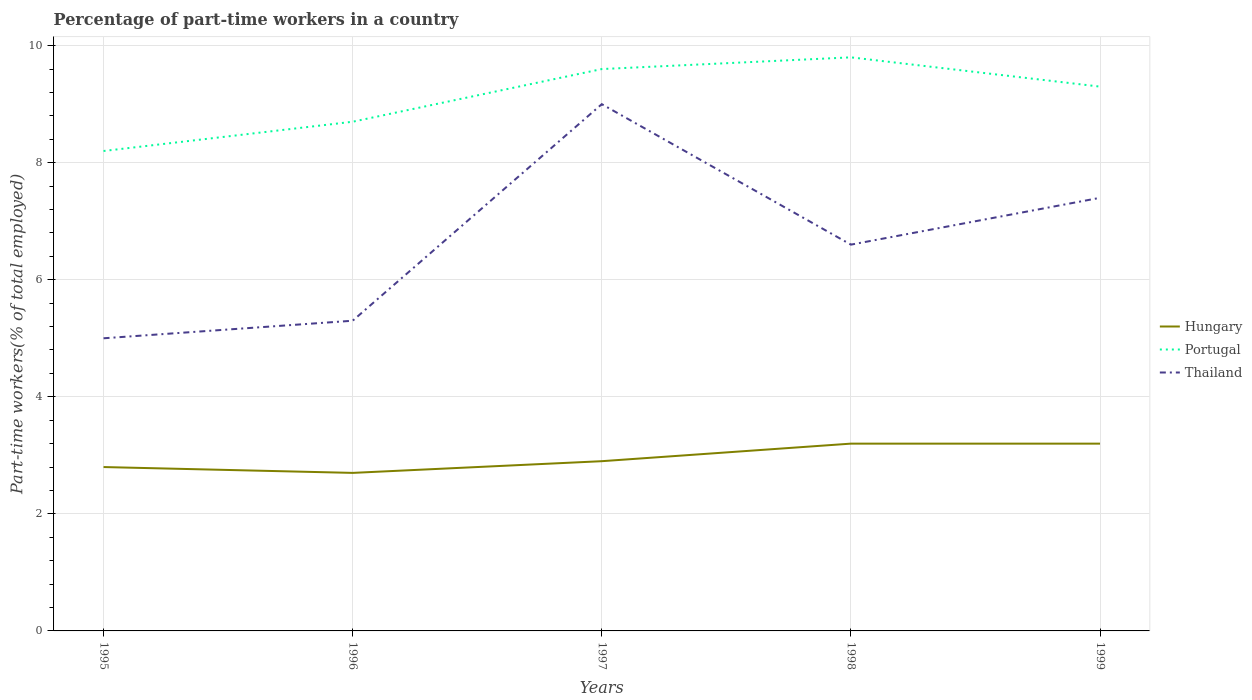How many different coloured lines are there?
Offer a very short reply. 3. Across all years, what is the maximum percentage of part-time workers in Hungary?
Keep it short and to the point. 2.7. What is the total percentage of part-time workers in Portugal in the graph?
Offer a terse response. -0.2. Is the percentage of part-time workers in Hungary strictly greater than the percentage of part-time workers in Thailand over the years?
Provide a succinct answer. Yes. How many lines are there?
Give a very brief answer. 3. How many years are there in the graph?
Your answer should be very brief. 5. Does the graph contain any zero values?
Provide a succinct answer. No. Does the graph contain grids?
Your response must be concise. Yes. How many legend labels are there?
Make the answer very short. 3. What is the title of the graph?
Ensure brevity in your answer.  Percentage of part-time workers in a country. Does "South Sudan" appear as one of the legend labels in the graph?
Your response must be concise. No. What is the label or title of the X-axis?
Provide a short and direct response. Years. What is the label or title of the Y-axis?
Your answer should be very brief. Part-time workers(% of total employed). What is the Part-time workers(% of total employed) in Hungary in 1995?
Your answer should be very brief. 2.8. What is the Part-time workers(% of total employed) of Portugal in 1995?
Offer a very short reply. 8.2. What is the Part-time workers(% of total employed) in Hungary in 1996?
Your answer should be compact. 2.7. What is the Part-time workers(% of total employed) of Portugal in 1996?
Offer a terse response. 8.7. What is the Part-time workers(% of total employed) in Thailand in 1996?
Your answer should be very brief. 5.3. What is the Part-time workers(% of total employed) in Hungary in 1997?
Offer a very short reply. 2.9. What is the Part-time workers(% of total employed) of Portugal in 1997?
Your answer should be compact. 9.6. What is the Part-time workers(% of total employed) of Hungary in 1998?
Your answer should be very brief. 3.2. What is the Part-time workers(% of total employed) in Portugal in 1998?
Your answer should be compact. 9.8. What is the Part-time workers(% of total employed) of Thailand in 1998?
Provide a succinct answer. 6.6. What is the Part-time workers(% of total employed) of Hungary in 1999?
Provide a short and direct response. 3.2. What is the Part-time workers(% of total employed) of Portugal in 1999?
Your answer should be compact. 9.3. What is the Part-time workers(% of total employed) in Thailand in 1999?
Keep it short and to the point. 7.4. Across all years, what is the maximum Part-time workers(% of total employed) of Hungary?
Offer a very short reply. 3.2. Across all years, what is the maximum Part-time workers(% of total employed) in Portugal?
Keep it short and to the point. 9.8. Across all years, what is the maximum Part-time workers(% of total employed) in Thailand?
Your response must be concise. 9. Across all years, what is the minimum Part-time workers(% of total employed) of Hungary?
Offer a very short reply. 2.7. Across all years, what is the minimum Part-time workers(% of total employed) in Portugal?
Provide a succinct answer. 8.2. What is the total Part-time workers(% of total employed) in Portugal in the graph?
Your answer should be compact. 45.6. What is the total Part-time workers(% of total employed) of Thailand in the graph?
Ensure brevity in your answer.  33.3. What is the difference between the Part-time workers(% of total employed) in Portugal in 1995 and that in 1997?
Offer a terse response. -1.4. What is the difference between the Part-time workers(% of total employed) in Hungary in 1995 and that in 1998?
Offer a very short reply. -0.4. What is the difference between the Part-time workers(% of total employed) in Thailand in 1995 and that in 1998?
Provide a short and direct response. -1.6. What is the difference between the Part-time workers(% of total employed) of Hungary in 1995 and that in 1999?
Your answer should be very brief. -0.4. What is the difference between the Part-time workers(% of total employed) in Portugal in 1995 and that in 1999?
Give a very brief answer. -1.1. What is the difference between the Part-time workers(% of total employed) of Hungary in 1996 and that in 1997?
Offer a very short reply. -0.2. What is the difference between the Part-time workers(% of total employed) of Portugal in 1996 and that in 1997?
Give a very brief answer. -0.9. What is the difference between the Part-time workers(% of total employed) of Thailand in 1996 and that in 1997?
Ensure brevity in your answer.  -3.7. What is the difference between the Part-time workers(% of total employed) of Hungary in 1996 and that in 1998?
Ensure brevity in your answer.  -0.5. What is the difference between the Part-time workers(% of total employed) of Portugal in 1996 and that in 1998?
Your answer should be very brief. -1.1. What is the difference between the Part-time workers(% of total employed) of Thailand in 1996 and that in 1998?
Keep it short and to the point. -1.3. What is the difference between the Part-time workers(% of total employed) of Hungary in 1996 and that in 1999?
Provide a short and direct response. -0.5. What is the difference between the Part-time workers(% of total employed) of Portugal in 1996 and that in 1999?
Your answer should be compact. -0.6. What is the difference between the Part-time workers(% of total employed) of Hungary in 1997 and that in 1998?
Your answer should be compact. -0.3. What is the difference between the Part-time workers(% of total employed) in Hungary in 1997 and that in 1999?
Provide a succinct answer. -0.3. What is the difference between the Part-time workers(% of total employed) in Portugal in 1997 and that in 1999?
Your answer should be compact. 0.3. What is the difference between the Part-time workers(% of total employed) in Portugal in 1998 and that in 1999?
Make the answer very short. 0.5. What is the difference between the Part-time workers(% of total employed) in Hungary in 1995 and the Part-time workers(% of total employed) in Portugal in 1996?
Offer a terse response. -5.9. What is the difference between the Part-time workers(% of total employed) of Hungary in 1995 and the Part-time workers(% of total employed) of Thailand in 1996?
Make the answer very short. -2.5. What is the difference between the Part-time workers(% of total employed) in Hungary in 1995 and the Part-time workers(% of total employed) in Portugal in 1997?
Give a very brief answer. -6.8. What is the difference between the Part-time workers(% of total employed) of Hungary in 1995 and the Part-time workers(% of total employed) of Thailand in 1997?
Your response must be concise. -6.2. What is the difference between the Part-time workers(% of total employed) of Hungary in 1995 and the Part-time workers(% of total employed) of Portugal in 1998?
Provide a succinct answer. -7. What is the difference between the Part-time workers(% of total employed) of Hungary in 1995 and the Part-time workers(% of total employed) of Thailand in 1998?
Make the answer very short. -3.8. What is the difference between the Part-time workers(% of total employed) of Portugal in 1995 and the Part-time workers(% of total employed) of Thailand in 1998?
Provide a short and direct response. 1.6. What is the difference between the Part-time workers(% of total employed) of Hungary in 1995 and the Part-time workers(% of total employed) of Portugal in 1999?
Your response must be concise. -6.5. What is the difference between the Part-time workers(% of total employed) in Portugal in 1995 and the Part-time workers(% of total employed) in Thailand in 1999?
Offer a very short reply. 0.8. What is the difference between the Part-time workers(% of total employed) in Hungary in 1996 and the Part-time workers(% of total employed) in Thailand in 1997?
Make the answer very short. -6.3. What is the difference between the Part-time workers(% of total employed) of Portugal in 1996 and the Part-time workers(% of total employed) of Thailand in 1997?
Your response must be concise. -0.3. What is the difference between the Part-time workers(% of total employed) of Hungary in 1996 and the Part-time workers(% of total employed) of Portugal in 1998?
Offer a very short reply. -7.1. What is the difference between the Part-time workers(% of total employed) of Hungary in 1997 and the Part-time workers(% of total employed) of Portugal in 1998?
Offer a very short reply. -6.9. What is the difference between the Part-time workers(% of total employed) of Hungary in 1997 and the Part-time workers(% of total employed) of Thailand in 1998?
Ensure brevity in your answer.  -3.7. What is the difference between the Part-time workers(% of total employed) in Hungary in 1997 and the Part-time workers(% of total employed) in Portugal in 1999?
Give a very brief answer. -6.4. What is the difference between the Part-time workers(% of total employed) in Hungary in 1997 and the Part-time workers(% of total employed) in Thailand in 1999?
Your response must be concise. -4.5. What is the difference between the Part-time workers(% of total employed) in Portugal in 1997 and the Part-time workers(% of total employed) in Thailand in 1999?
Offer a very short reply. 2.2. What is the difference between the Part-time workers(% of total employed) of Hungary in 1998 and the Part-time workers(% of total employed) of Portugal in 1999?
Provide a succinct answer. -6.1. What is the difference between the Part-time workers(% of total employed) in Portugal in 1998 and the Part-time workers(% of total employed) in Thailand in 1999?
Provide a succinct answer. 2.4. What is the average Part-time workers(% of total employed) of Hungary per year?
Your answer should be very brief. 2.96. What is the average Part-time workers(% of total employed) of Portugal per year?
Make the answer very short. 9.12. What is the average Part-time workers(% of total employed) of Thailand per year?
Keep it short and to the point. 6.66. In the year 1995, what is the difference between the Part-time workers(% of total employed) of Hungary and Part-time workers(% of total employed) of Portugal?
Give a very brief answer. -5.4. In the year 1995, what is the difference between the Part-time workers(% of total employed) in Hungary and Part-time workers(% of total employed) in Thailand?
Ensure brevity in your answer.  -2.2. In the year 1995, what is the difference between the Part-time workers(% of total employed) in Portugal and Part-time workers(% of total employed) in Thailand?
Give a very brief answer. 3.2. In the year 1997, what is the difference between the Part-time workers(% of total employed) of Hungary and Part-time workers(% of total employed) of Portugal?
Offer a very short reply. -6.7. In the year 1997, what is the difference between the Part-time workers(% of total employed) in Portugal and Part-time workers(% of total employed) in Thailand?
Offer a terse response. 0.6. In the year 1998, what is the difference between the Part-time workers(% of total employed) of Hungary and Part-time workers(% of total employed) of Portugal?
Keep it short and to the point. -6.6. In the year 1998, what is the difference between the Part-time workers(% of total employed) in Hungary and Part-time workers(% of total employed) in Thailand?
Your response must be concise. -3.4. In the year 1999, what is the difference between the Part-time workers(% of total employed) in Hungary and Part-time workers(% of total employed) in Portugal?
Give a very brief answer. -6.1. In the year 1999, what is the difference between the Part-time workers(% of total employed) in Hungary and Part-time workers(% of total employed) in Thailand?
Provide a succinct answer. -4.2. What is the ratio of the Part-time workers(% of total employed) of Hungary in 1995 to that in 1996?
Your answer should be very brief. 1.04. What is the ratio of the Part-time workers(% of total employed) in Portugal in 1995 to that in 1996?
Provide a short and direct response. 0.94. What is the ratio of the Part-time workers(% of total employed) of Thailand in 1995 to that in 1996?
Give a very brief answer. 0.94. What is the ratio of the Part-time workers(% of total employed) in Hungary in 1995 to that in 1997?
Make the answer very short. 0.97. What is the ratio of the Part-time workers(% of total employed) of Portugal in 1995 to that in 1997?
Your response must be concise. 0.85. What is the ratio of the Part-time workers(% of total employed) of Thailand in 1995 to that in 1997?
Your answer should be compact. 0.56. What is the ratio of the Part-time workers(% of total employed) in Hungary in 1995 to that in 1998?
Provide a succinct answer. 0.88. What is the ratio of the Part-time workers(% of total employed) in Portugal in 1995 to that in 1998?
Keep it short and to the point. 0.84. What is the ratio of the Part-time workers(% of total employed) in Thailand in 1995 to that in 1998?
Give a very brief answer. 0.76. What is the ratio of the Part-time workers(% of total employed) in Portugal in 1995 to that in 1999?
Offer a terse response. 0.88. What is the ratio of the Part-time workers(% of total employed) in Thailand in 1995 to that in 1999?
Offer a very short reply. 0.68. What is the ratio of the Part-time workers(% of total employed) of Portugal in 1996 to that in 1997?
Keep it short and to the point. 0.91. What is the ratio of the Part-time workers(% of total employed) of Thailand in 1996 to that in 1997?
Your answer should be compact. 0.59. What is the ratio of the Part-time workers(% of total employed) in Hungary in 1996 to that in 1998?
Provide a short and direct response. 0.84. What is the ratio of the Part-time workers(% of total employed) of Portugal in 1996 to that in 1998?
Give a very brief answer. 0.89. What is the ratio of the Part-time workers(% of total employed) of Thailand in 1996 to that in 1998?
Offer a terse response. 0.8. What is the ratio of the Part-time workers(% of total employed) of Hungary in 1996 to that in 1999?
Your answer should be very brief. 0.84. What is the ratio of the Part-time workers(% of total employed) in Portugal in 1996 to that in 1999?
Your response must be concise. 0.94. What is the ratio of the Part-time workers(% of total employed) of Thailand in 1996 to that in 1999?
Your answer should be very brief. 0.72. What is the ratio of the Part-time workers(% of total employed) in Hungary in 1997 to that in 1998?
Your response must be concise. 0.91. What is the ratio of the Part-time workers(% of total employed) in Portugal in 1997 to that in 1998?
Your answer should be compact. 0.98. What is the ratio of the Part-time workers(% of total employed) of Thailand in 1997 to that in 1998?
Offer a terse response. 1.36. What is the ratio of the Part-time workers(% of total employed) in Hungary in 1997 to that in 1999?
Provide a succinct answer. 0.91. What is the ratio of the Part-time workers(% of total employed) of Portugal in 1997 to that in 1999?
Provide a short and direct response. 1.03. What is the ratio of the Part-time workers(% of total employed) in Thailand in 1997 to that in 1999?
Provide a succinct answer. 1.22. What is the ratio of the Part-time workers(% of total employed) in Hungary in 1998 to that in 1999?
Your response must be concise. 1. What is the ratio of the Part-time workers(% of total employed) of Portugal in 1998 to that in 1999?
Provide a short and direct response. 1.05. What is the ratio of the Part-time workers(% of total employed) of Thailand in 1998 to that in 1999?
Ensure brevity in your answer.  0.89. What is the difference between the highest and the second highest Part-time workers(% of total employed) in Hungary?
Offer a terse response. 0. What is the difference between the highest and the second highest Part-time workers(% of total employed) in Portugal?
Your answer should be very brief. 0.2. What is the difference between the highest and the second highest Part-time workers(% of total employed) in Thailand?
Provide a succinct answer. 1.6. 